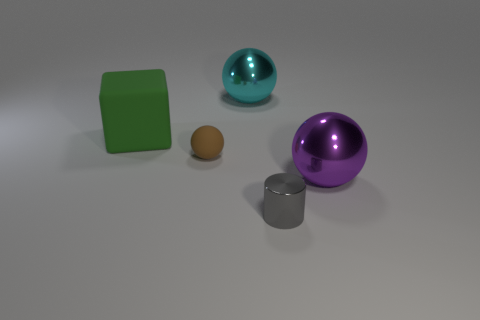Does the big cyan thing have the same shape as the small brown rubber object? Yes, both the large cyan object, which appears to be a spherical ball, and the small brown object have a spherical shape, despite the difference in size and material. 